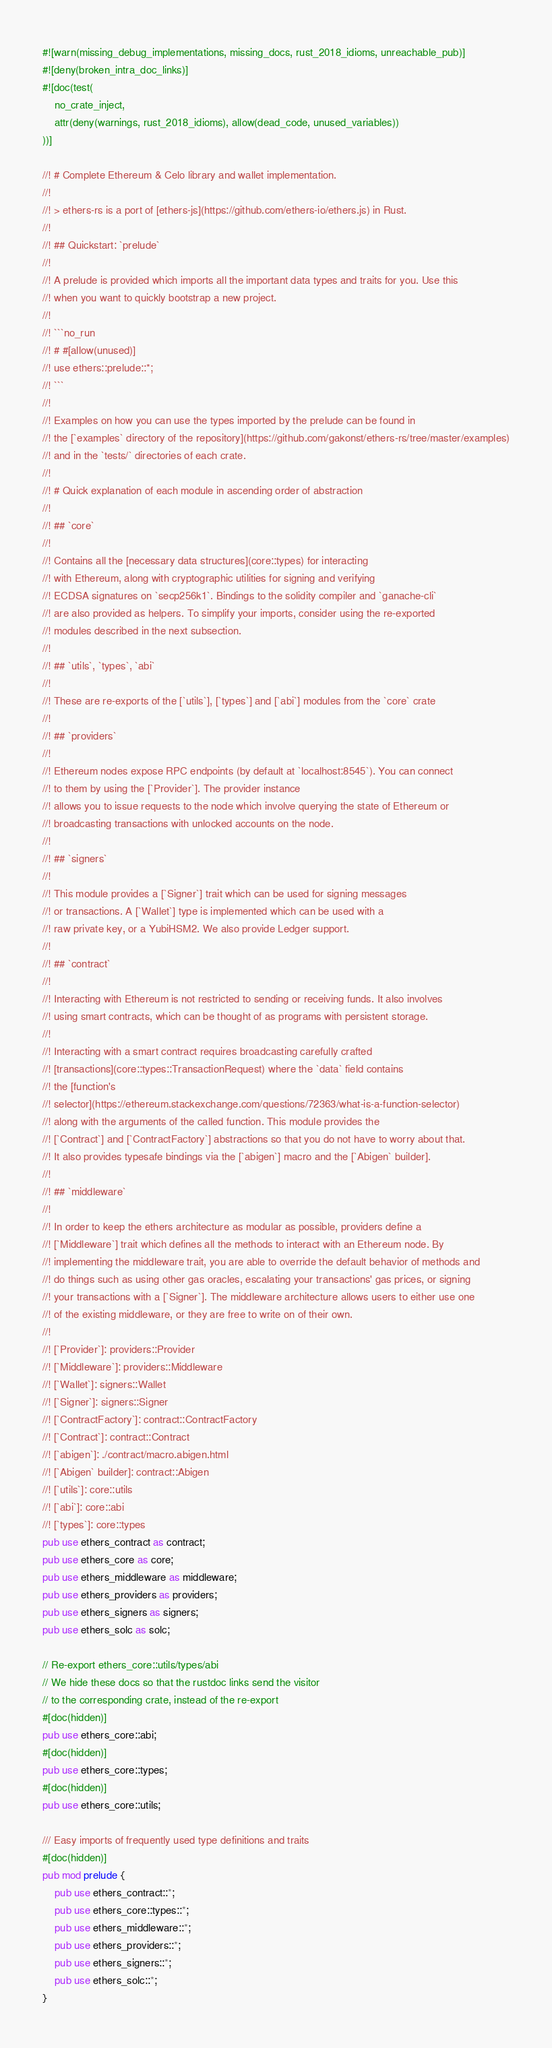<code> <loc_0><loc_0><loc_500><loc_500><_Rust_>#![warn(missing_debug_implementations, missing_docs, rust_2018_idioms, unreachable_pub)]
#![deny(broken_intra_doc_links)]
#![doc(test(
    no_crate_inject,
    attr(deny(warnings, rust_2018_idioms), allow(dead_code, unused_variables))
))]

//! # Complete Ethereum & Celo library and wallet implementation.
//!
//! > ethers-rs is a port of [ethers-js](https://github.com/ethers-io/ethers.js) in Rust.
//!
//! ## Quickstart: `prelude`
//!
//! A prelude is provided which imports all the important data types and traits for you. Use this
//! when you want to quickly bootstrap a new project.
//!
//! ```no_run
//! # #[allow(unused)]
//! use ethers::prelude::*;
//! ```
//!
//! Examples on how you can use the types imported by the prelude can be found in
//! the [`examples` directory of the repository](https://github.com/gakonst/ethers-rs/tree/master/examples)
//! and in the `tests/` directories of each crate.
//!
//! # Quick explanation of each module in ascending order of abstraction
//!
//! ## `core`
//!
//! Contains all the [necessary data structures](core::types) for interacting
//! with Ethereum, along with cryptographic utilities for signing and verifying
//! ECDSA signatures on `secp256k1`. Bindings to the solidity compiler and `ganache-cli`
//! are also provided as helpers. To simplify your imports, consider using the re-exported
//! modules described in the next subsection.
//!
//! ## `utils`, `types`, `abi`
//!
//! These are re-exports of the [`utils`], [`types`] and [`abi`] modules from the `core` crate
//!
//! ## `providers`
//!
//! Ethereum nodes expose RPC endpoints (by default at `localhost:8545`). You can connect
//! to them by using the [`Provider`]. The provider instance
//! allows you to issue requests to the node which involve querying the state of Ethereum or
//! broadcasting transactions with unlocked accounts on the node.
//!
//! ## `signers`
//!
//! This module provides a [`Signer`] trait which can be used for signing messages
//! or transactions. A [`Wallet`] type is implemented which can be used with a
//! raw private key, or a YubiHSM2. We also provide Ledger support.
//!
//! ## `contract`
//!
//! Interacting with Ethereum is not restricted to sending or receiving funds. It also involves
//! using smart contracts, which can be thought of as programs with persistent storage.
//!
//! Interacting with a smart contract requires broadcasting carefully crafted
//! [transactions](core::types::TransactionRequest) where the `data` field contains
//! the [function's
//! selector](https://ethereum.stackexchange.com/questions/72363/what-is-a-function-selector)
//! along with the arguments of the called function. This module provides the
//! [`Contract`] and [`ContractFactory`] abstractions so that you do not have to worry about that.
//! It also provides typesafe bindings via the [`abigen`] macro and the [`Abigen` builder].
//!
//! ## `middleware`
//!
//! In order to keep the ethers architecture as modular as possible, providers define a
//! [`Middleware`] trait which defines all the methods to interact with an Ethereum node. By
//! implementing the middleware trait, you are able to override the default behavior of methods and
//! do things such as using other gas oracles, escalating your transactions' gas prices, or signing
//! your transactions with a [`Signer`]. The middleware architecture allows users to either use one
//! of the existing middleware, or they are free to write on of their own.
//!
//! [`Provider`]: providers::Provider
//! [`Middleware`]: providers::Middleware
//! [`Wallet`]: signers::Wallet
//! [`Signer`]: signers::Signer
//! [`ContractFactory`]: contract::ContractFactory
//! [`Contract`]: contract::Contract
//! [`abigen`]: ./contract/macro.abigen.html
//! [`Abigen` builder]: contract::Abigen
//! [`utils`]: core::utils
//! [`abi`]: core::abi
//! [`types`]: core::types
pub use ethers_contract as contract;
pub use ethers_core as core;
pub use ethers_middleware as middleware;
pub use ethers_providers as providers;
pub use ethers_signers as signers;
pub use ethers_solc as solc;

// Re-export ethers_core::utils/types/abi
// We hide these docs so that the rustdoc links send the visitor
// to the corresponding crate, instead of the re-export
#[doc(hidden)]
pub use ethers_core::abi;
#[doc(hidden)]
pub use ethers_core::types;
#[doc(hidden)]
pub use ethers_core::utils;

/// Easy imports of frequently used type definitions and traits
#[doc(hidden)]
pub mod prelude {
    pub use ethers_contract::*;
    pub use ethers_core::types::*;
    pub use ethers_middleware::*;
    pub use ethers_providers::*;
    pub use ethers_signers::*;
    pub use ethers_solc::*;
}
</code> 